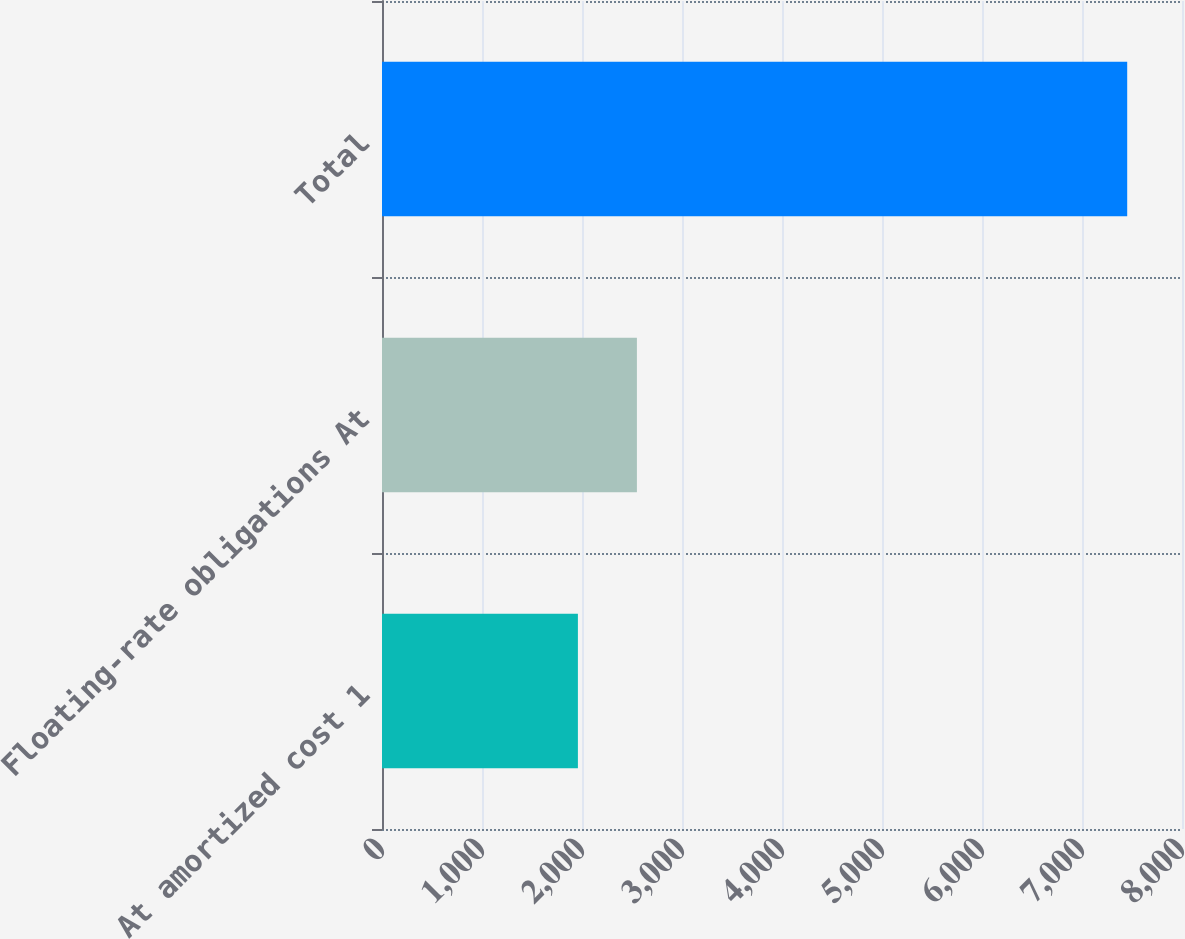Convert chart. <chart><loc_0><loc_0><loc_500><loc_500><bar_chart><fcel>At amortized cost 1<fcel>Floating-rate obligations At<fcel>Total<nl><fcel>1959<fcel>2549<fcel>7452<nl></chart> 